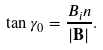<formula> <loc_0><loc_0><loc_500><loc_500>\tan \gamma _ { 0 } = \frac { B _ { i } n } { | { \mathbf B } | } .</formula> 